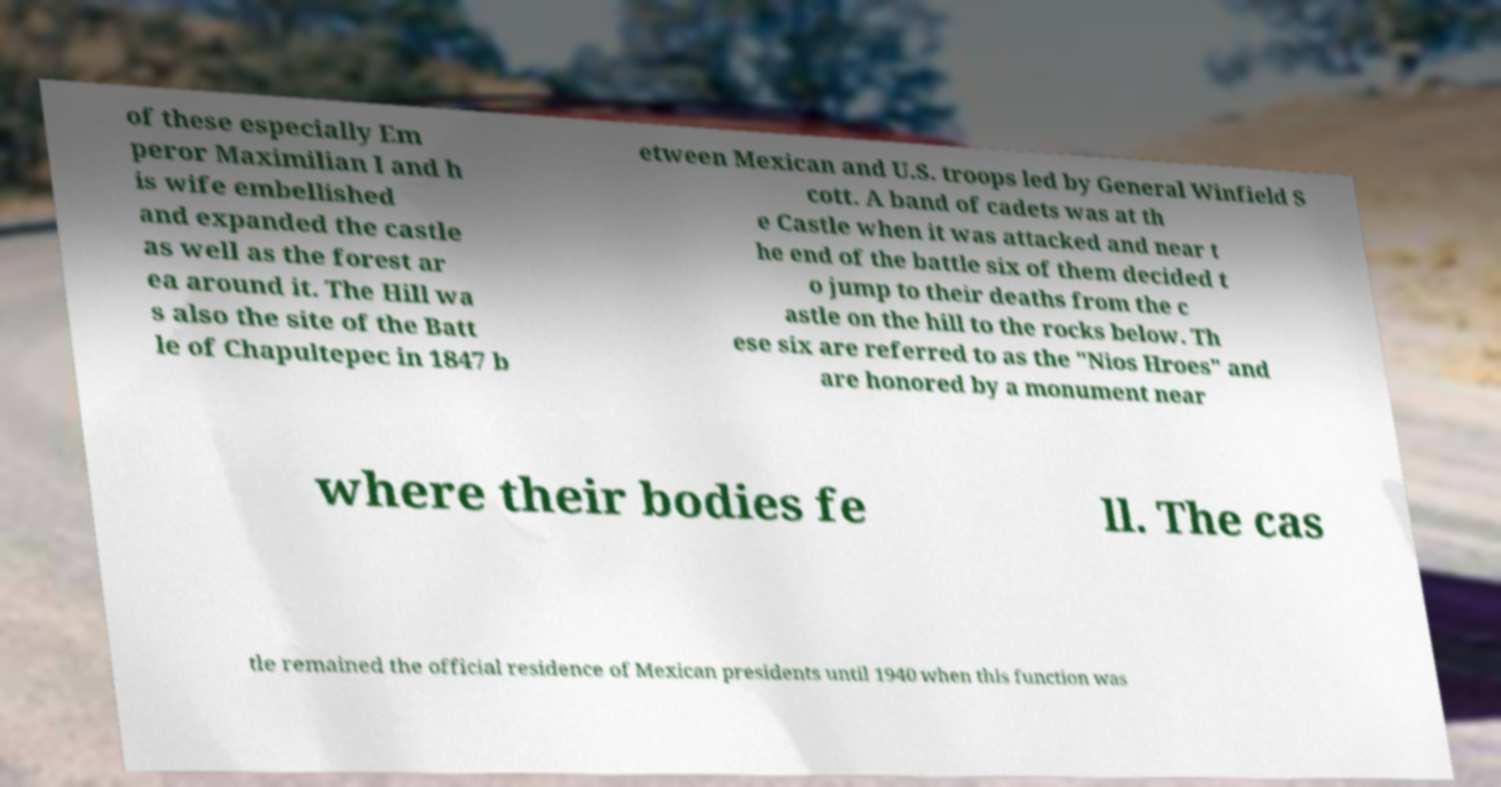Can you read and provide the text displayed in the image?This photo seems to have some interesting text. Can you extract and type it out for me? of these especially Em peror Maximilian I and h is wife embellished and expanded the castle as well as the forest ar ea around it. The Hill wa s also the site of the Batt le of Chapultepec in 1847 b etween Mexican and U.S. troops led by General Winfield S cott. A band of cadets was at th e Castle when it was attacked and near t he end of the battle six of them decided t o jump to their deaths from the c astle on the hill to the rocks below. Th ese six are referred to as the "Nios Hroes" and are honored by a monument near where their bodies fe ll. The cas tle remained the official residence of Mexican presidents until 1940 when this function was 